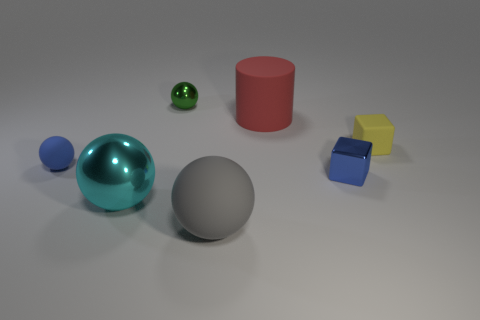Do the matte ball in front of the metallic block and the blue rubber ball have the same size?
Provide a short and direct response. No. There is a thing that is both to the left of the big gray rubber object and behind the yellow rubber object; what is its size?
Your answer should be compact. Small. What number of red matte things are the same size as the blue block?
Make the answer very short. 0. What number of matte objects are right of the small sphere that is in front of the matte cylinder?
Make the answer very short. 3. There is a big matte ball to the right of the large cyan metallic thing; does it have the same color as the cylinder?
Offer a terse response. No. Are there any small things that are behind the cube that is behind the tiny sphere in front of the large cylinder?
Your answer should be compact. Yes. What is the shape of the object that is to the right of the red matte cylinder and behind the small blue metallic object?
Give a very brief answer. Cube. Is there a small shiny thing of the same color as the large cylinder?
Provide a succinct answer. No. What is the color of the shiny thing to the left of the green thing that is behind the tiny blue shiny object?
Your answer should be very brief. Cyan. There is a metallic sphere that is behind the blue thing on the right side of the object that is behind the large red cylinder; what is its size?
Your answer should be very brief. Small. 